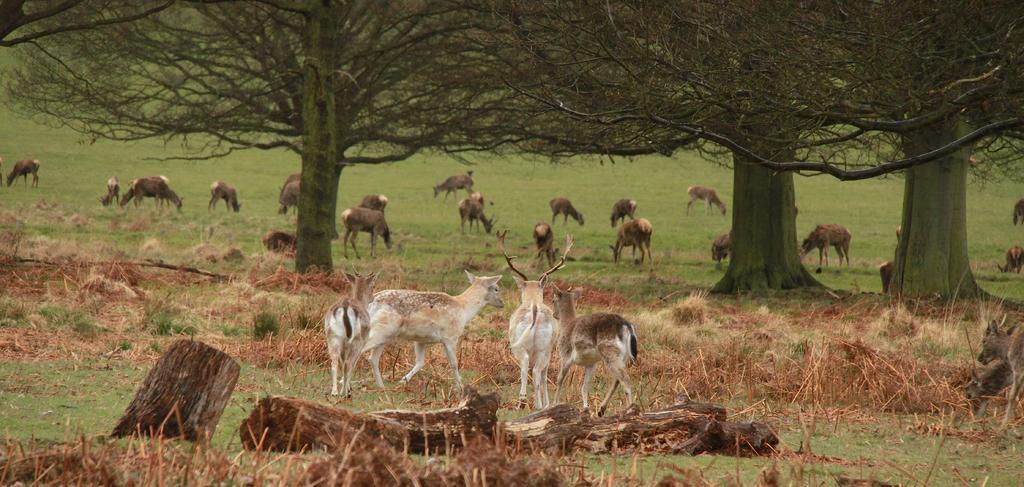Please provide a concise description of this image. In this picture there are deers in the center of the image there are lots at the bottom side of the image and there are grass land and trees in the background area of the image. 